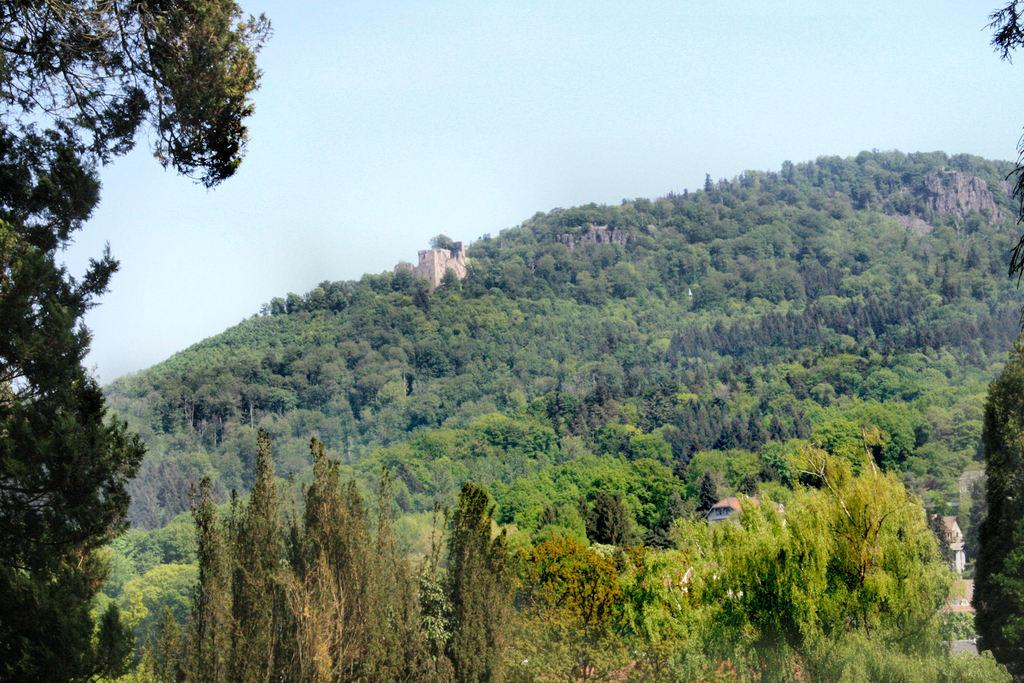What type of natural elements can be seen in the image? There are trees in the image. What type of man-made structures are present in the image? There are buildings in the image. What color is the sky in the image? The sky is blue in the image. How many kittens are playing on the bridge in the image? There is no bridge or kittens present in the image. 